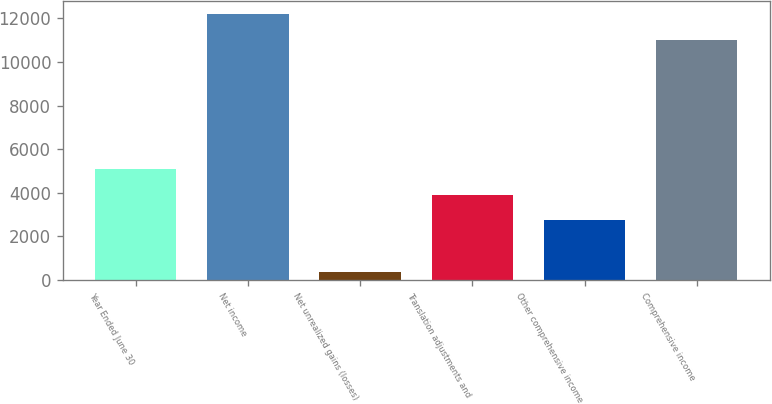Convert chart to OTSL. <chart><loc_0><loc_0><loc_500><loc_500><bar_chart><fcel>Year Ended June 30<fcel>Net income<fcel>Net unrealized gains (losses)<fcel>Translation adjustments and<fcel>Other comprehensive income<fcel>Comprehensive income<nl><fcel>5094.4<fcel>12193<fcel>362<fcel>3911.3<fcel>2728.2<fcel>11007<nl></chart> 